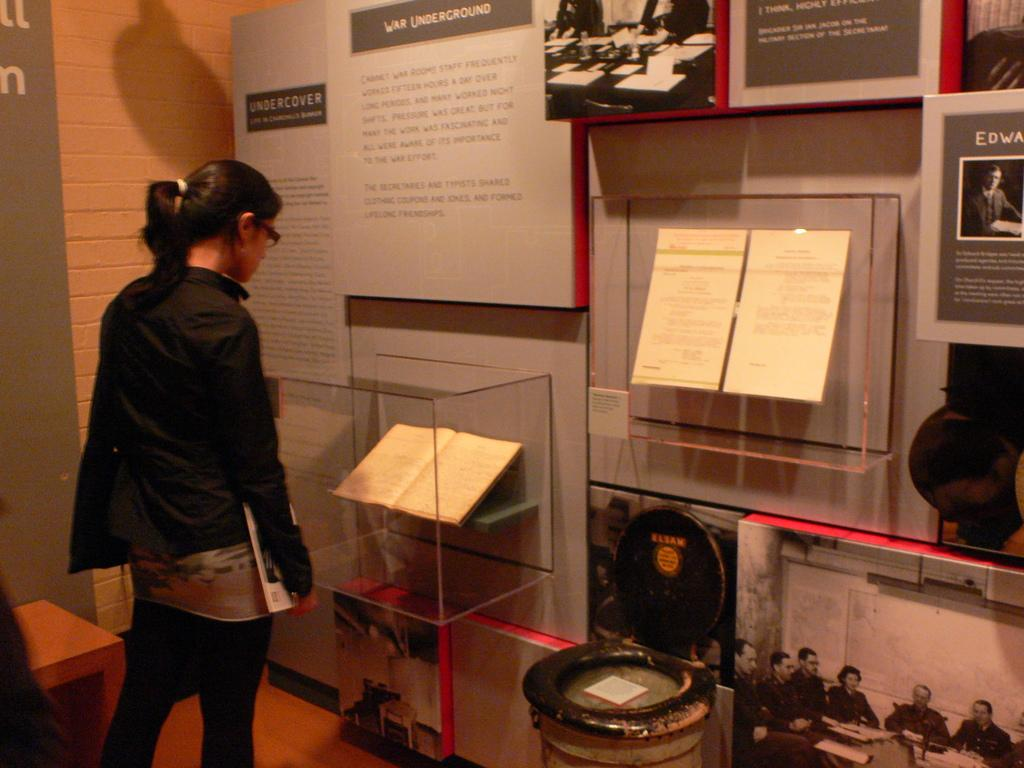Who is present in the image? There is a woman in the image. What is the woman doing in the image? The woman is standing and looking at a book. How is the woman interacting with the book? The woman is holding a book in her hand. What can be seen on the wall in the image? There are posters on the wall. Can you tell me how many goldfish are swimming in the book the woman is holding? There are no goldfish present in the image, and the book is not depicted as containing any water or aquatic life. 